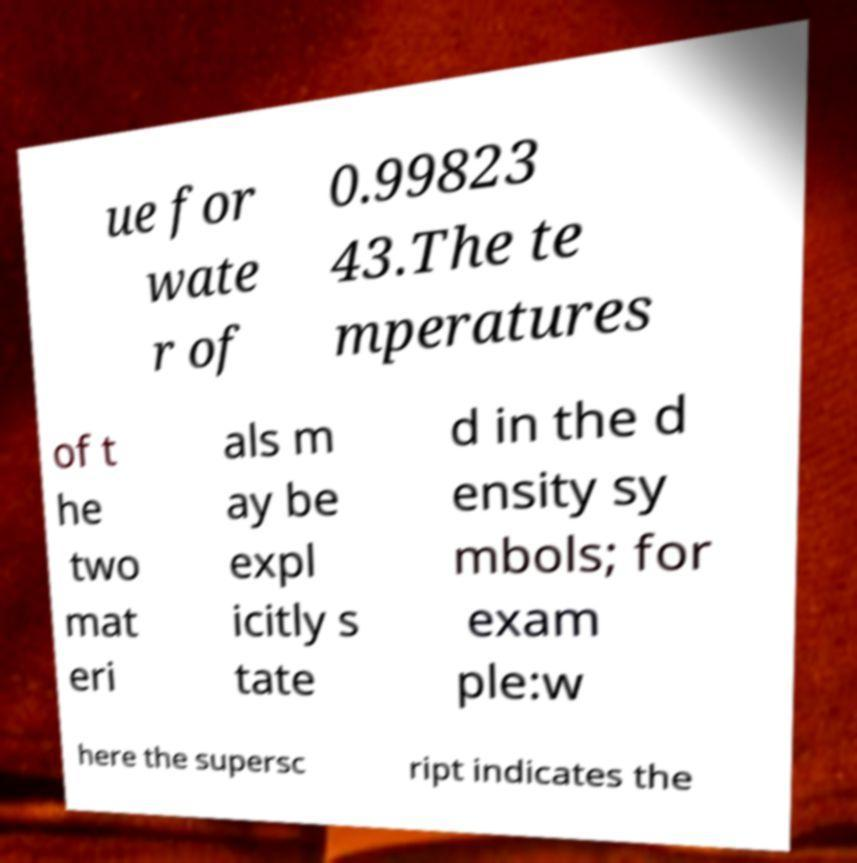What messages or text are displayed in this image? I need them in a readable, typed format. ue for wate r of 0.99823 43.The te mperatures of t he two mat eri als m ay be expl icitly s tate d in the d ensity sy mbols; for exam ple:w here the supersc ript indicates the 